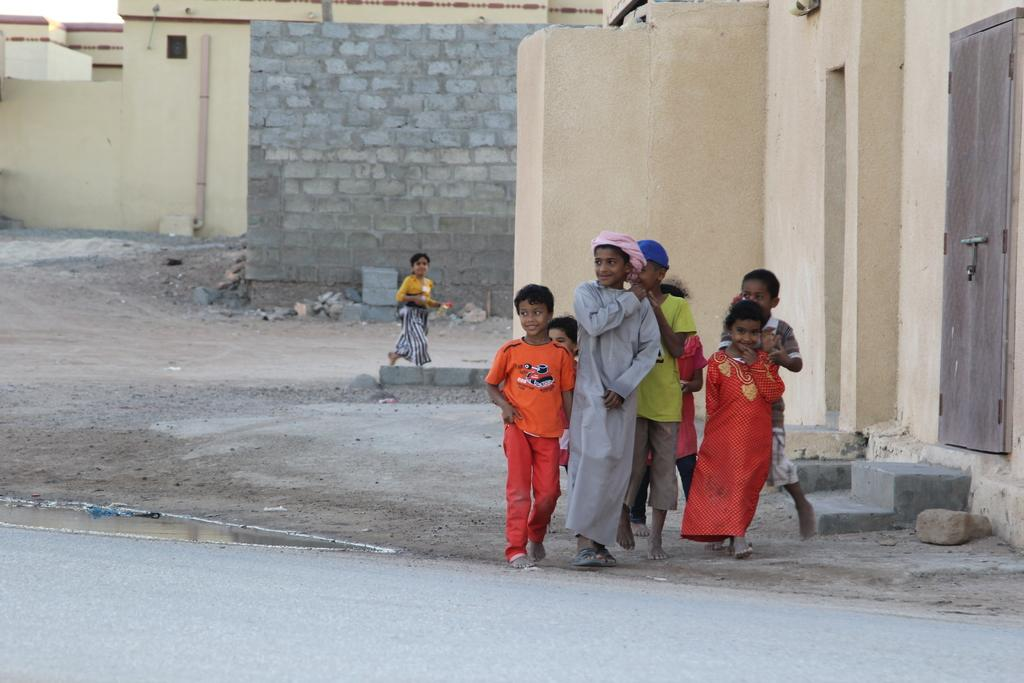What is the main subject of the image? The main subject of the image is a group of kids. What are the kids doing in the image? The kids are standing and smiling in the image. What can be seen in the background of the image? There are buildings, water, rocks, and a road visible in the image. What type of harmony can be heard in the image? There is no audible sound in the image, so it is not possible to determine the type of harmony present. 